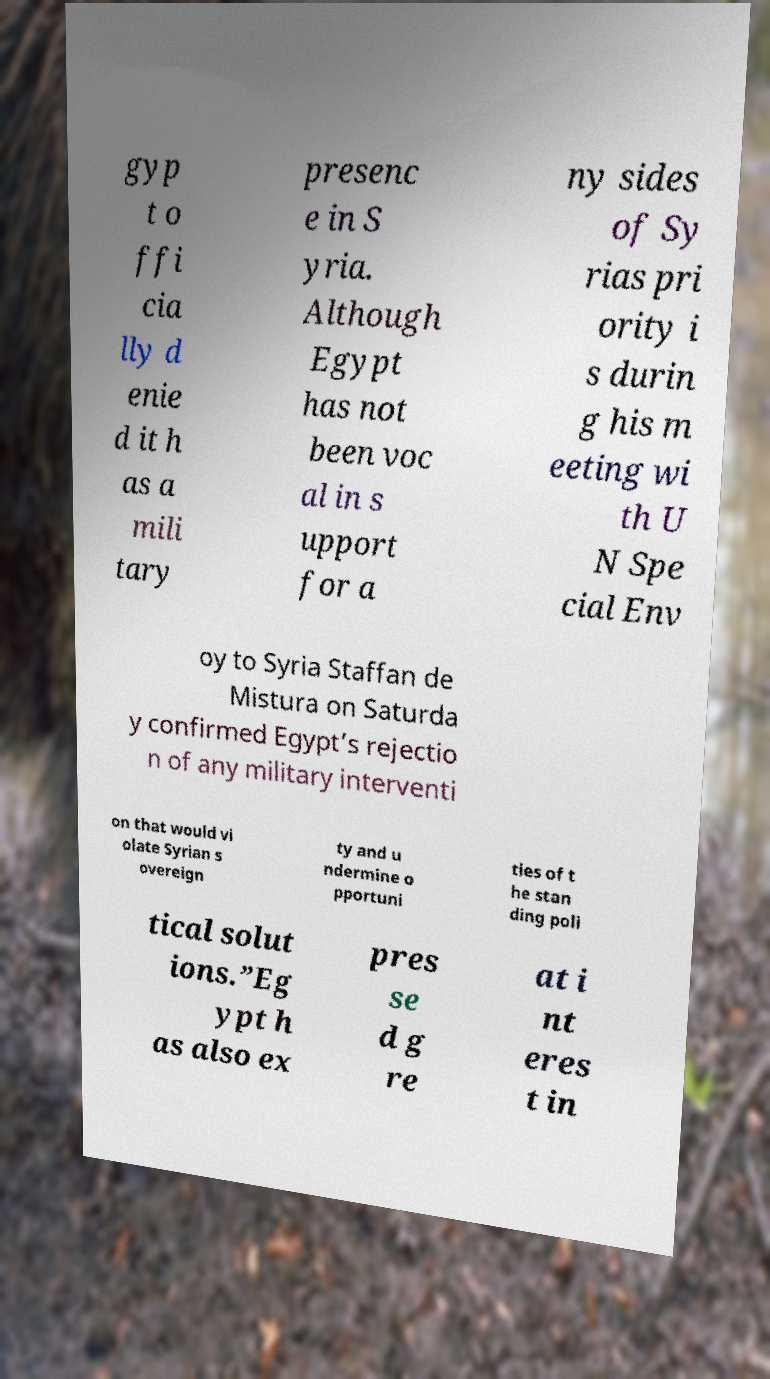Can you accurately transcribe the text from the provided image for me? gyp t o ffi cia lly d enie d it h as a mili tary presenc e in S yria. Although Egypt has not been voc al in s upport for a ny sides of Sy rias pri ority i s durin g his m eeting wi th U N Spe cial Env oy to Syria Staffan de Mistura on Saturda y confirmed Egypt’s rejectio n of any military interventi on that would vi olate Syrian s overeign ty and u ndermine o pportuni ties of t he stan ding poli tical solut ions.”Eg ypt h as also ex pres se d g re at i nt eres t in 